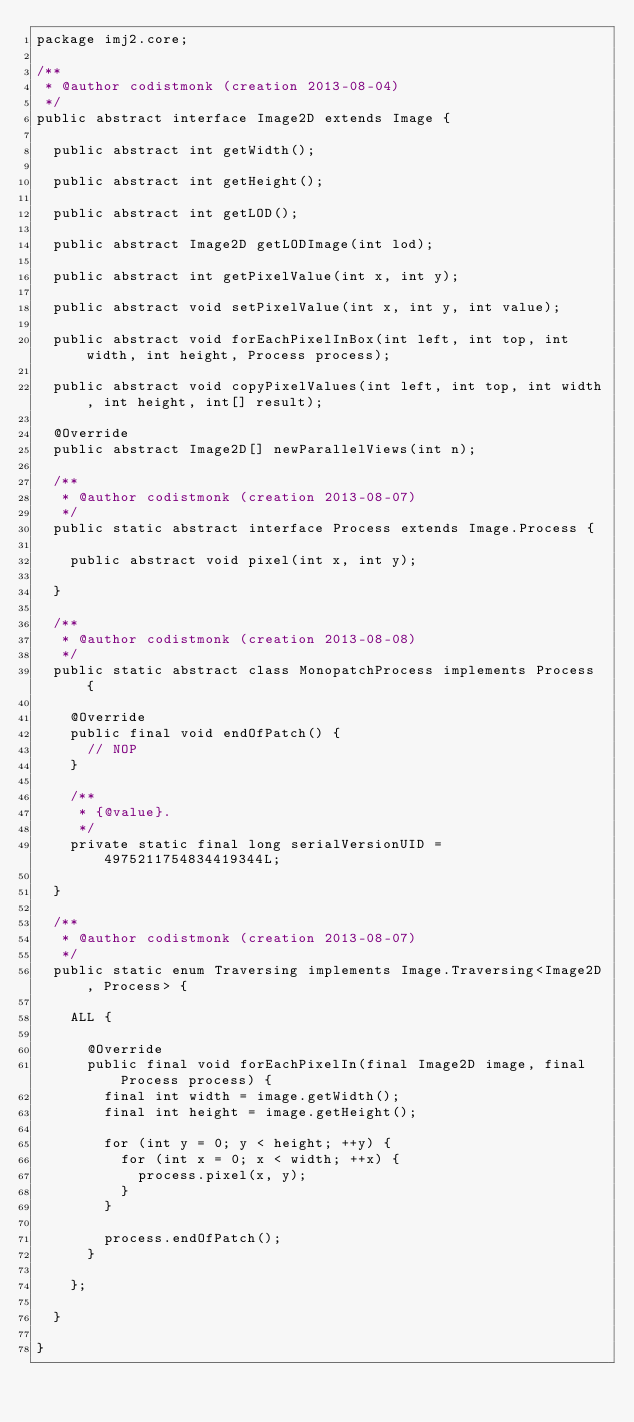Convert code to text. <code><loc_0><loc_0><loc_500><loc_500><_Java_>package imj2.core;

/**
 * @author codistmonk (creation 2013-08-04)
 */
public abstract interface Image2D extends Image {
	
	public abstract int getWidth();
	
	public abstract int getHeight();
	
	public abstract int getLOD();
	
	public abstract Image2D getLODImage(int lod);
	
	public abstract int getPixelValue(int x, int y);
	
	public abstract void setPixelValue(int x, int y, int value);
	
	public abstract void forEachPixelInBox(int left, int top, int width, int height, Process process);
	
	public abstract void copyPixelValues(int left, int top, int width, int height, int[] result);
	
	@Override
	public abstract Image2D[] newParallelViews(int n);
	
	/**
	 * @author codistmonk (creation 2013-08-07)
	 */
	public static abstract interface Process extends Image.Process {
		
		public abstract void pixel(int x, int y);
		
	}
	
	/**
	 * @author codistmonk (creation 2013-08-08)
	 */
	public static abstract class MonopatchProcess implements Process {
		
		@Override
		public final void endOfPatch() {
			// NOP
		}
		
		/**
		 * {@value}.
		 */
		private static final long serialVersionUID = 4975211754834419344L;
		
	}
	
	/**
	 * @author codistmonk (creation 2013-08-07)
	 */
	public static enum Traversing implements Image.Traversing<Image2D, Process> {
		
		ALL {
			
			@Override
			public final void forEachPixelIn(final Image2D image, final Process process) {
				final int width = image.getWidth();
				final int height = image.getHeight();
				
				for (int y = 0; y < height; ++y) {
					for (int x = 0; x < width; ++x) {
						process.pixel(x, y);
					}
				}
				
				process.endOfPatch();
			}
			
		};
		
	}
	
}
</code> 